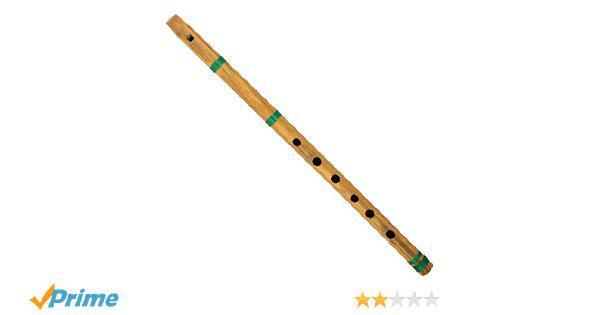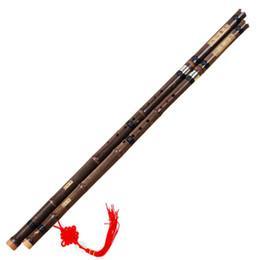The first image is the image on the left, the second image is the image on the right. Analyze the images presented: Is the assertion "There are two flutes in the left image." valid? Answer yes or no. No. The first image is the image on the left, the second image is the image on the right. Assess this claim about the two images: "The left image contains a single flute displayed at an angle, and the right image contains at least one flute displayed at an angle opposite that of the flute on the left.". Correct or not? Answer yes or no. Yes. 